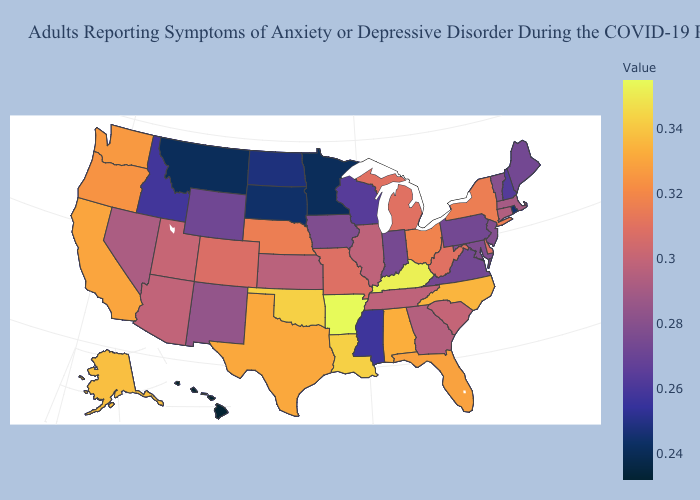Which states hav the highest value in the Northeast?
Concise answer only. New York. Does the map have missing data?
Quick response, please. No. Which states have the lowest value in the USA?
Be succinct. Hawaii. Does Indiana have the lowest value in the USA?
Short answer required. No. 